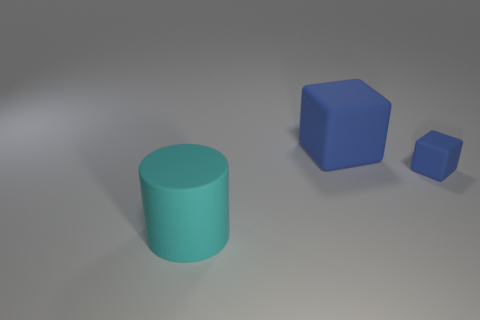Add 2 big rubber blocks. How many objects exist? 5 Subtract all blocks. How many objects are left? 1 Add 3 big blue things. How many big blue things exist? 4 Subtract 0 cyan blocks. How many objects are left? 3 Subtract all large yellow shiny cylinders. Subtract all big blue matte objects. How many objects are left? 2 Add 2 tiny blue rubber objects. How many tiny blue rubber objects are left? 3 